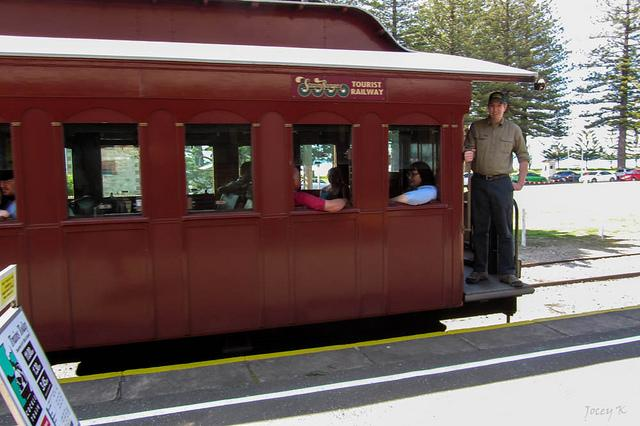What type passengers board this train?

Choices:
A) commuters
B) none
C) tourists
D) engineers only tourists 